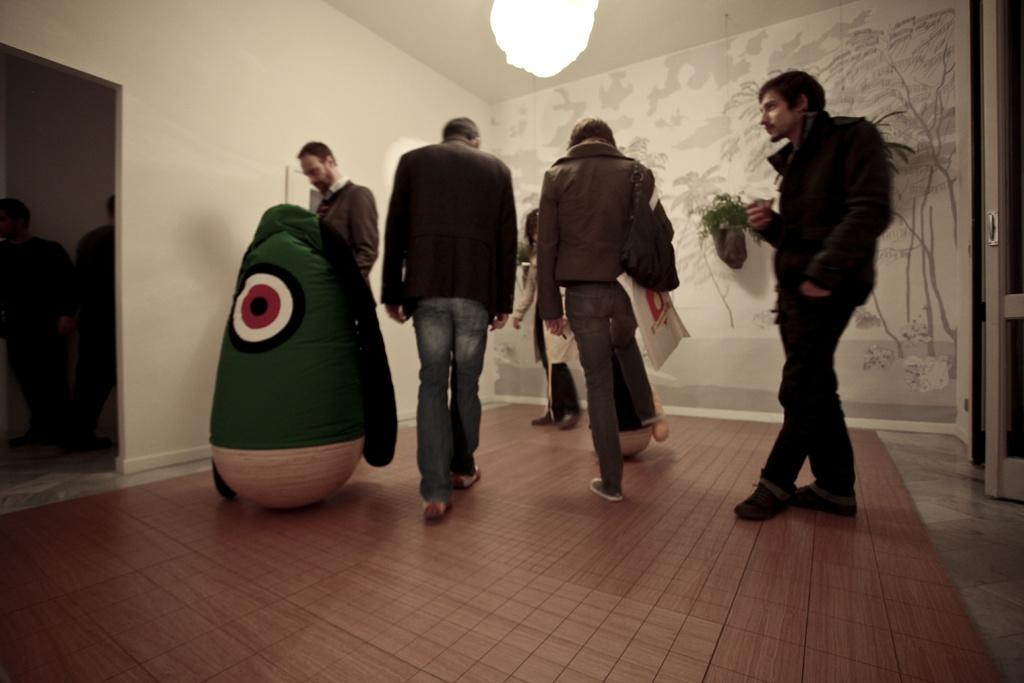What can be seen in the image? There is a group of people in the image. What else is present in the image besides the people? There are toys and flower pots on the wall in the background of the image. Can you describe the lighting in the image? There is a light at the top of the image. What type of bucket is being used by the people in the image? There is no bucket present in the image. 